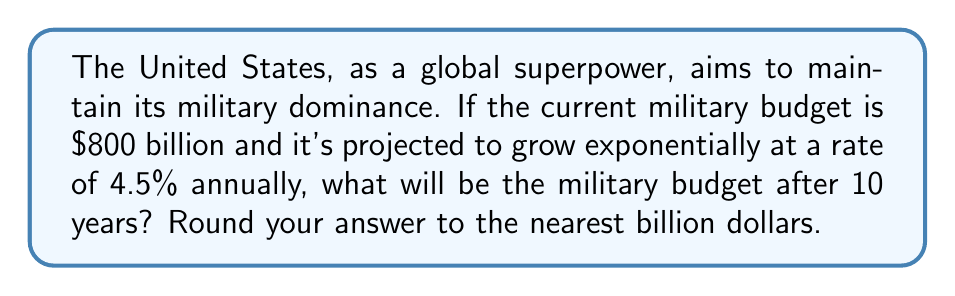Solve this math problem. Let's approach this step-by-step using the exponential growth formula:

1) The exponential growth formula is:
   $A = P(1 + r)^t$
   Where:
   $A$ = final amount
   $P$ = initial principal balance
   $r$ = annual growth rate (in decimal form)
   $t$ = time in years

2) We know:
   $P = 800$ billion (initial budget)
   $r = 0.045$ (4.5% written as a decimal)
   $t = 10$ years

3) Let's substitute these values into our formula:
   $A = 800(1 + 0.045)^{10}$

4) Simplify inside the parentheses:
   $A = 800(1.045)^{10}$

5) Calculate $(1.045)^{10}$:
   $(1.045)^{10} \approx 1.5530$

6) Multiply:
   $A = 800 \times 1.5530 = 1,242.4$ billion

7) Rounding to the nearest billion:
   $A \approx 1,242$ billion
Answer: $1,242 billion 